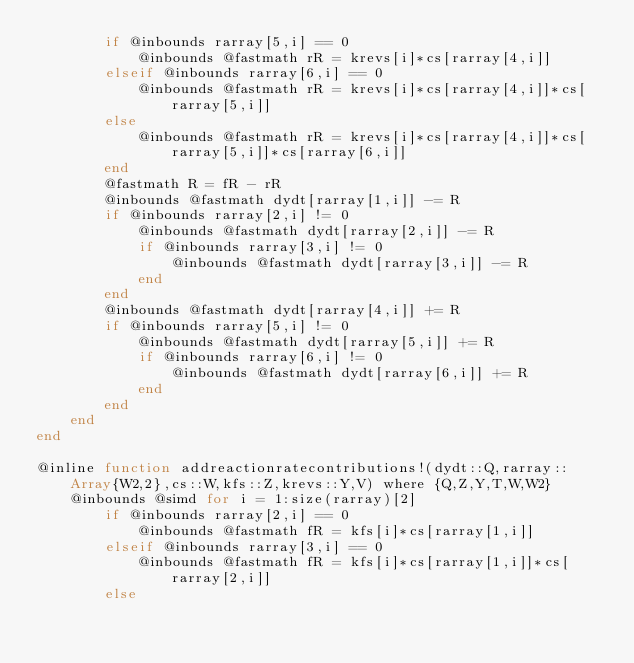<code> <loc_0><loc_0><loc_500><loc_500><_Julia_>        if @inbounds rarray[5,i] == 0
            @inbounds @fastmath rR = krevs[i]*cs[rarray[4,i]]
        elseif @inbounds rarray[6,i] == 0
            @inbounds @fastmath rR = krevs[i]*cs[rarray[4,i]]*cs[rarray[5,i]]
        else
            @inbounds @fastmath rR = krevs[i]*cs[rarray[4,i]]*cs[rarray[5,i]]*cs[rarray[6,i]]
        end
        @fastmath R = fR - rR
        @inbounds @fastmath dydt[rarray[1,i]] -= R
        if @inbounds rarray[2,i] != 0
            @inbounds @fastmath dydt[rarray[2,i]] -= R
            if @inbounds rarray[3,i] != 0
                @inbounds @fastmath dydt[rarray[3,i]] -= R
            end
        end
        @inbounds @fastmath dydt[rarray[4,i]] += R
        if @inbounds rarray[5,i] != 0
            @inbounds @fastmath dydt[rarray[5,i]] += R
            if @inbounds rarray[6,i] != 0
                @inbounds @fastmath dydt[rarray[6,i]] += R
            end
        end
    end
end

@inline function addreactionratecontributions!(dydt::Q,rarray::Array{W2,2},cs::W,kfs::Z,krevs::Y,V) where {Q,Z,Y,T,W,W2}
    @inbounds @simd for i = 1:size(rarray)[2]
        if @inbounds rarray[2,i] == 0
            @inbounds @fastmath fR = kfs[i]*cs[rarray[1,i]]
        elseif @inbounds rarray[3,i] == 0
            @inbounds @fastmath fR = kfs[i]*cs[rarray[1,i]]*cs[rarray[2,i]]
        else</code> 